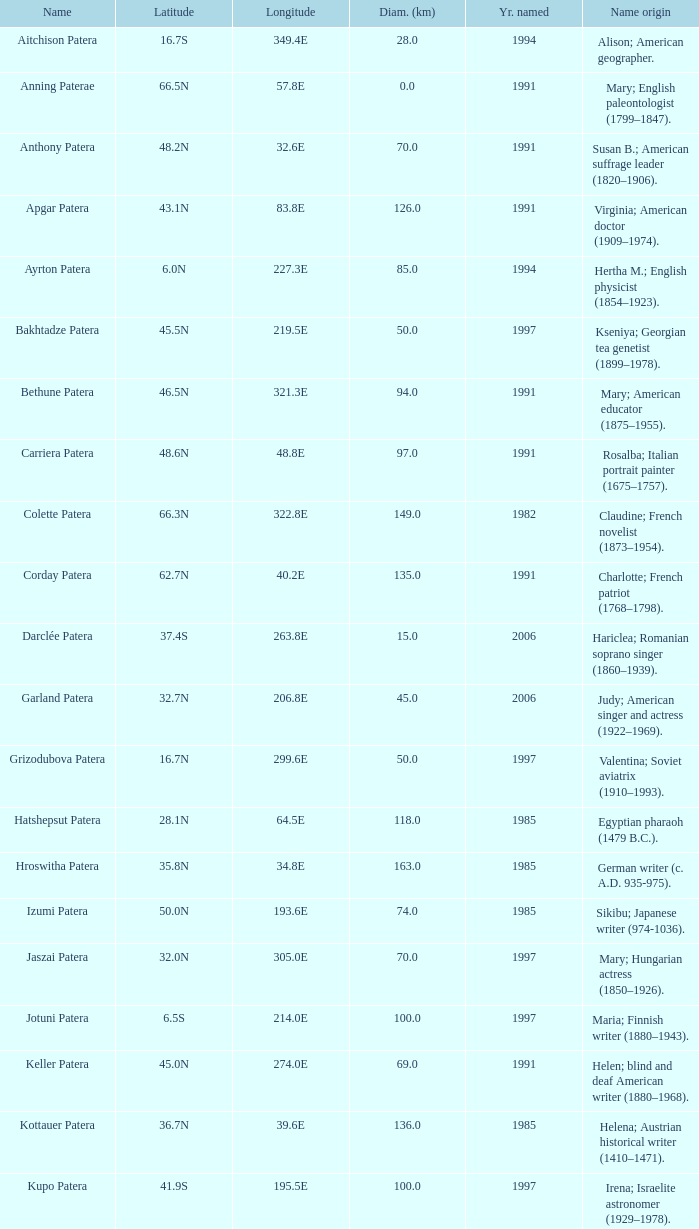In what year was the feature at a 33.3S latitude named?  2000.0. 